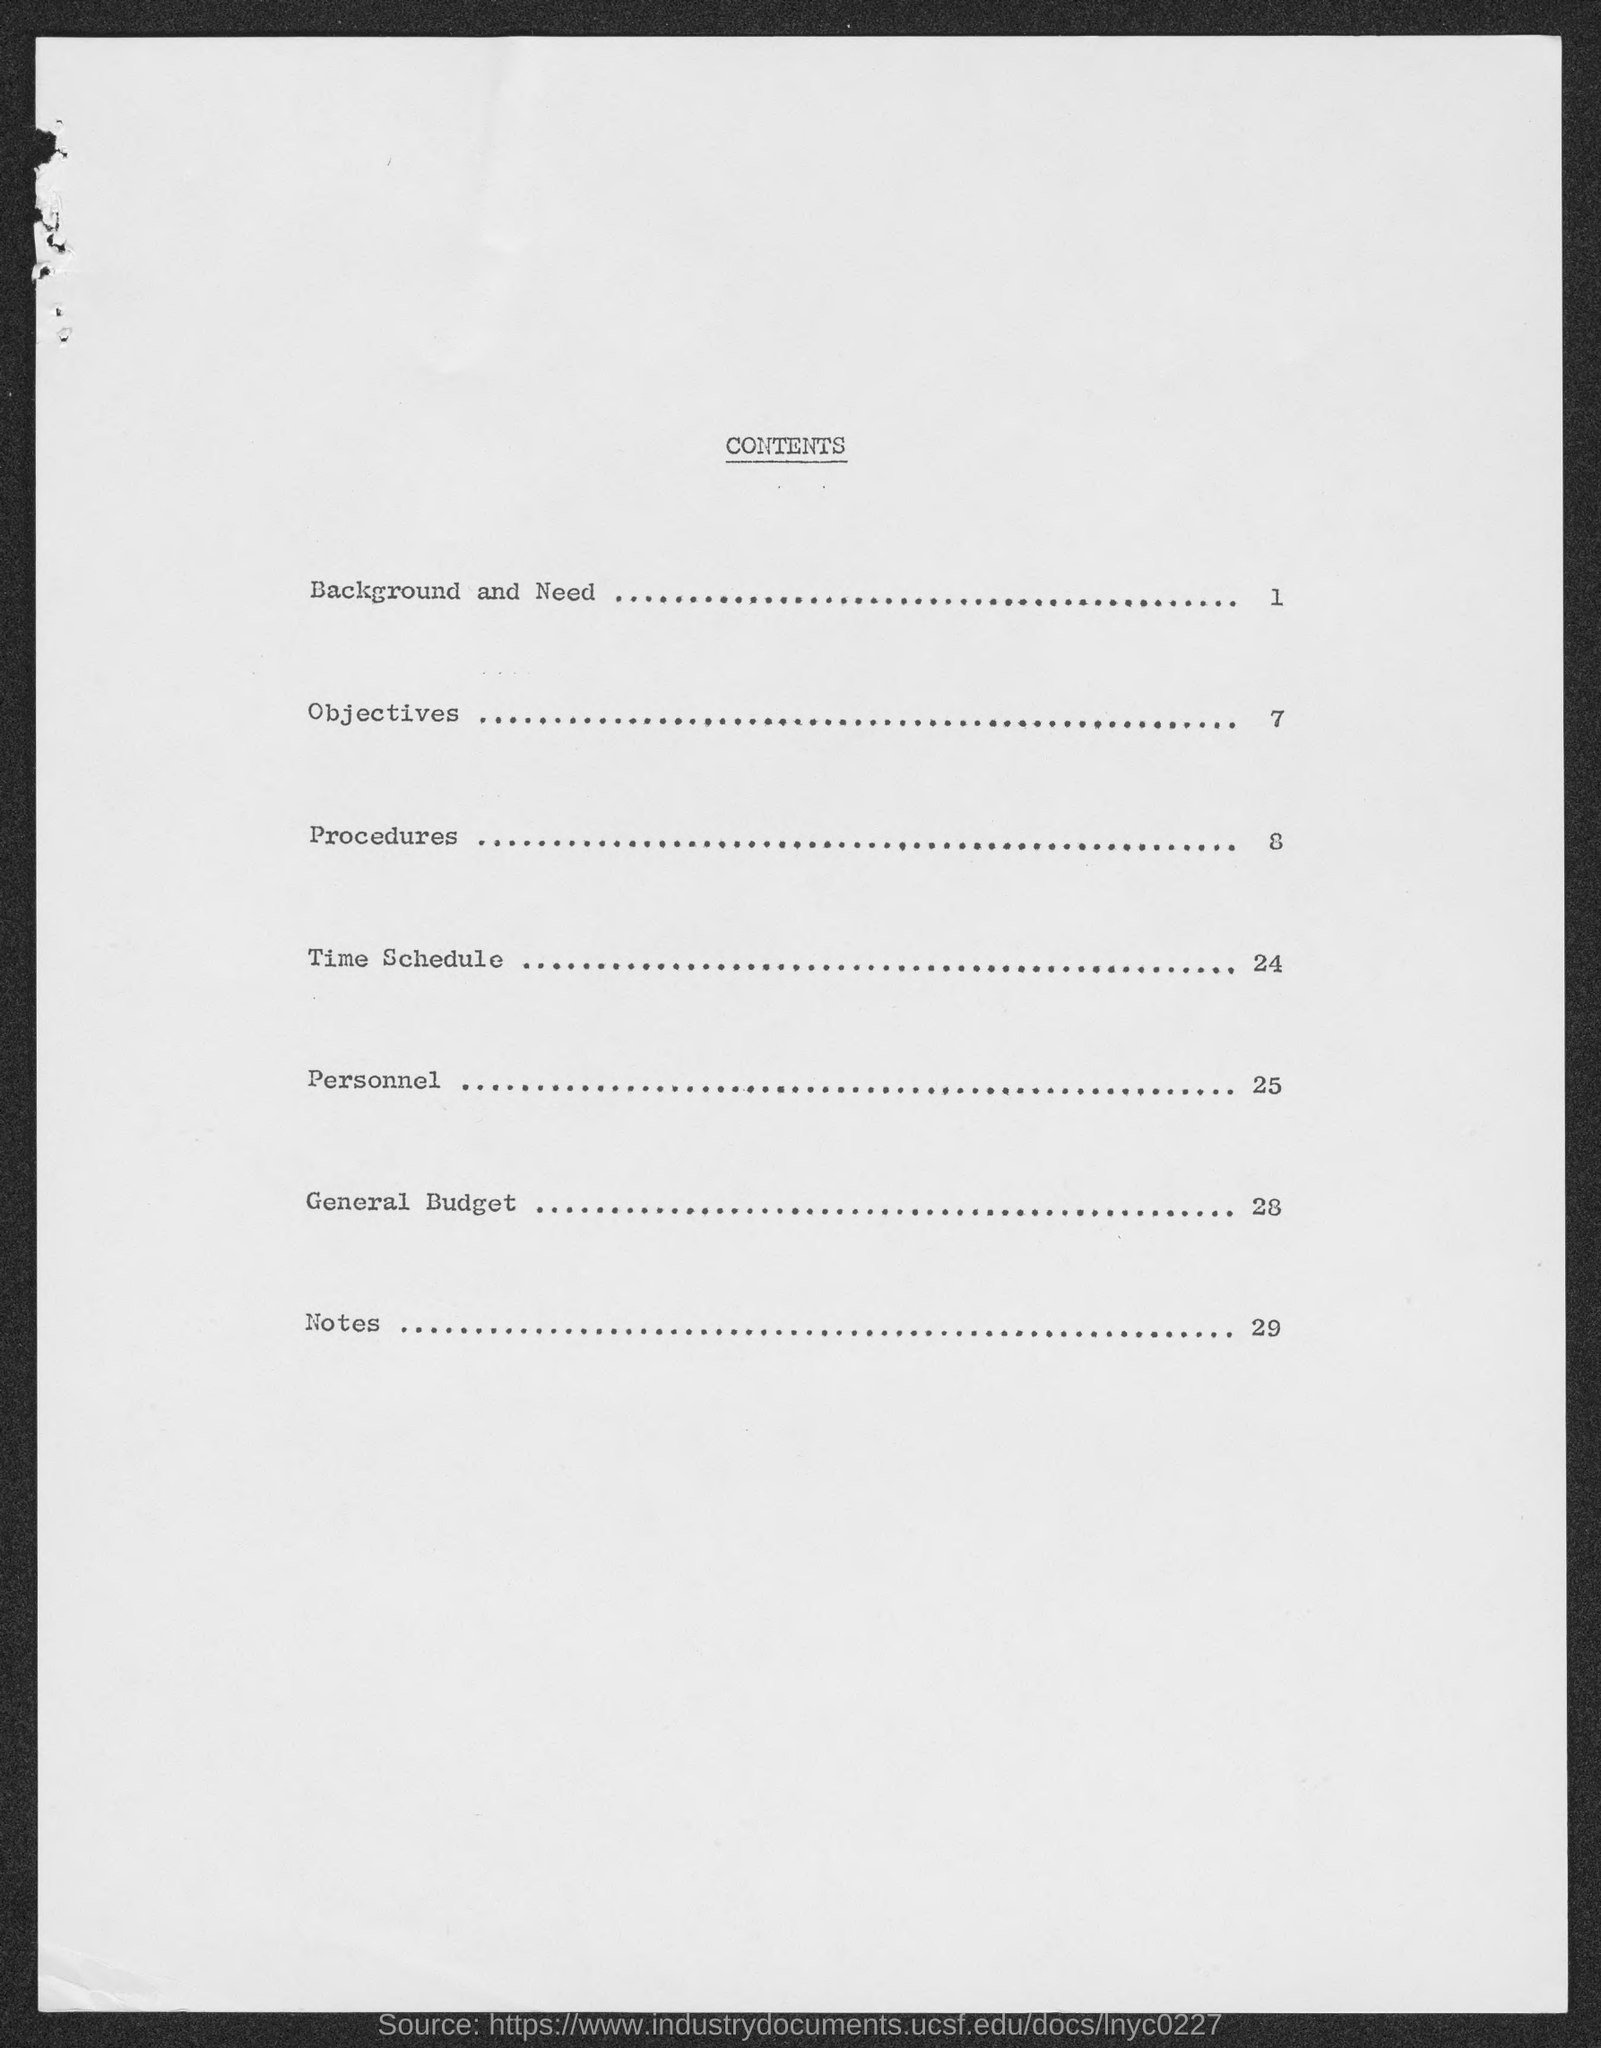Indicate a few pertinent items in this graphic. The general budget details are mentioned in Page 28. The subject line of Page 24 is 'Time Schedule.' The background and need for the proposed research project is discussed in page number 1. 